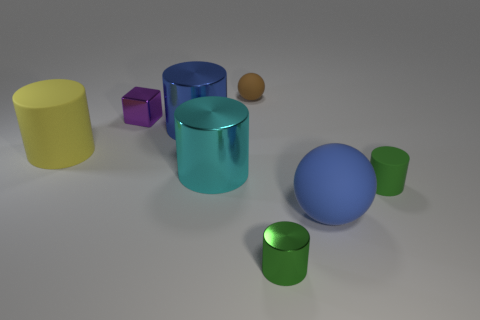What material is the cube that is the same size as the green metallic cylinder?
Your response must be concise. Metal. There is a thing that is to the right of the big blue rubber object; what color is it?
Your answer should be very brief. Green. What number of matte objects are there?
Make the answer very short. 4. Is there a small green rubber thing that is right of the small matte thing in front of the big blue thing that is to the left of the brown thing?
Offer a very short reply. No. There is a blue metal thing that is the same size as the blue matte ball; what is its shape?
Provide a short and direct response. Cylinder. How many other things are there of the same color as the metallic block?
Make the answer very short. 0. What is the material of the large yellow thing?
Provide a short and direct response. Rubber. What number of other objects are there of the same material as the brown object?
Keep it short and to the point. 3. There is a matte object that is both left of the tiny green metallic cylinder and to the right of the purple metal object; what size is it?
Give a very brief answer. Small. What shape is the big rubber thing that is to the right of the large thing that is behind the large yellow cylinder?
Give a very brief answer. Sphere. 